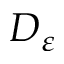<formula> <loc_0><loc_0><loc_500><loc_500>D _ { \varepsilon }</formula> 